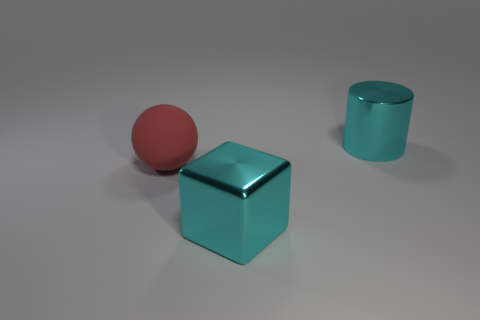There is a metal object that is the same color as the big block; what size is it?
Ensure brevity in your answer.  Large. There is a large cyan thing in front of the big sphere; what shape is it?
Give a very brief answer. Cube. How many objects are behind the shiny thing that is right of the object that is in front of the big red ball?
Give a very brief answer. 0. Is the size of the cyan shiny cylinder the same as the thing that is in front of the large rubber thing?
Provide a short and direct response. Yes. There is a cyan metal thing that is in front of the big metal thing to the right of the large metallic block; how big is it?
Ensure brevity in your answer.  Large. What number of other big cyan cylinders are made of the same material as the big cyan cylinder?
Provide a short and direct response. 0. Is there a metal block?
Provide a succinct answer. Yes. There is a metal thing that is to the left of the cylinder; what is its size?
Give a very brief answer. Large. How many metal cubes have the same color as the large cylinder?
Your answer should be very brief. 1. How many balls are either cyan shiny things or large purple objects?
Your response must be concise. 0. 